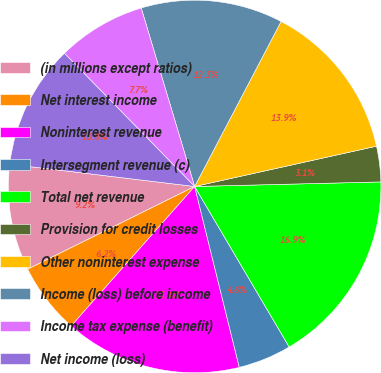Convert chart to OTSL. <chart><loc_0><loc_0><loc_500><loc_500><pie_chart><fcel>(in millions except ratios)<fcel>Net interest income<fcel>Noninterest revenue<fcel>Intersegment revenue (c)<fcel>Total net revenue<fcel>Provision for credit losses<fcel>Other noninterest expense<fcel>Income (loss) before income<fcel>Income tax expense (benefit)<fcel>Net income (loss)<nl><fcel>9.23%<fcel>6.15%<fcel>15.38%<fcel>4.62%<fcel>16.92%<fcel>3.08%<fcel>13.85%<fcel>12.31%<fcel>7.69%<fcel>10.77%<nl></chart> 